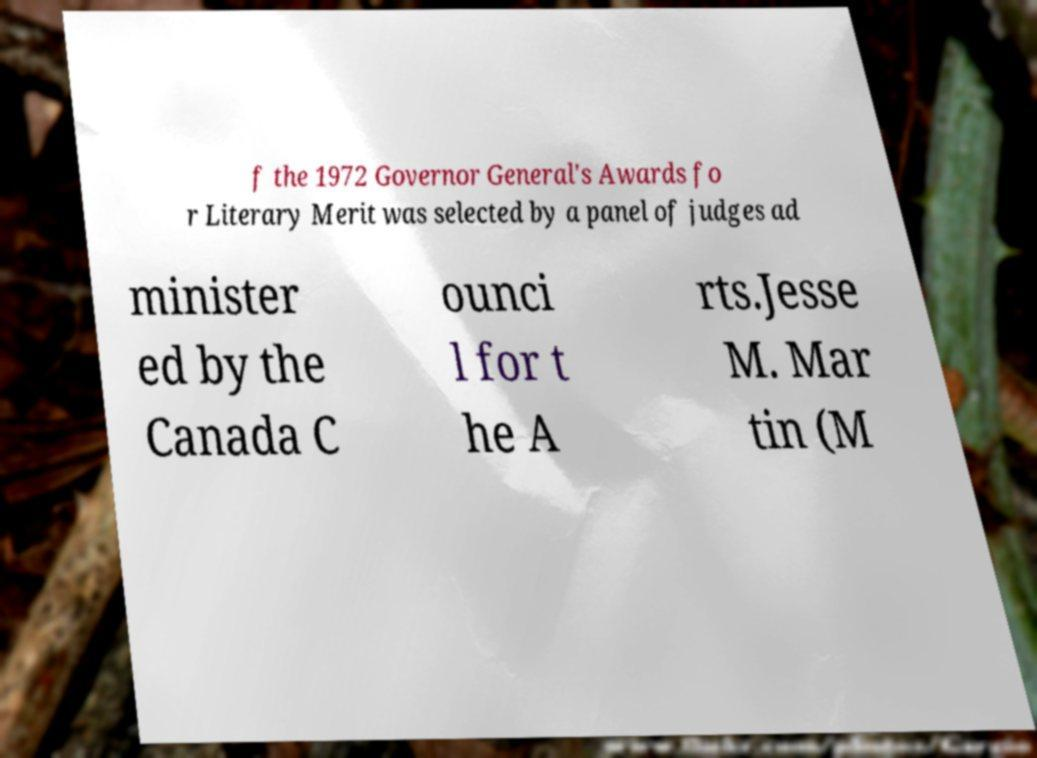Can you read and provide the text displayed in the image?This photo seems to have some interesting text. Can you extract and type it out for me? f the 1972 Governor General's Awards fo r Literary Merit was selected by a panel of judges ad minister ed by the Canada C ounci l for t he A rts.Jesse M. Mar tin (M 